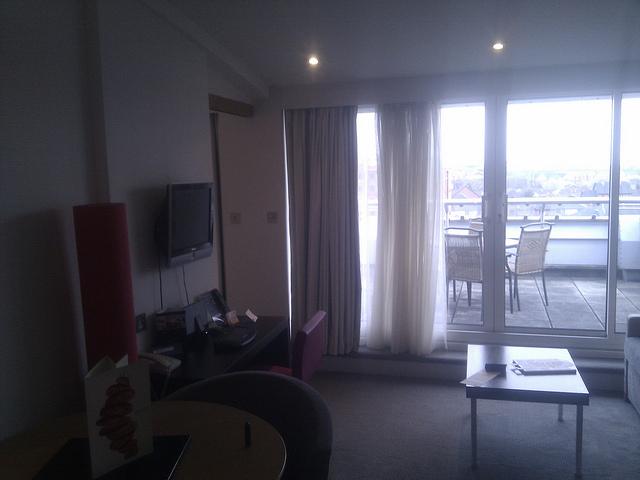What type of scene is it?
Write a very short answer. Living room. Which room is this?
Quick response, please. Living room. What bridge can be seen in the distance?
Give a very brief answer. Golden gate. Where is the balcony?
Quick response, please. Outside. What color are the curtains?
Write a very short answer. White. What style of architecture is this?
Answer briefly. Modern. What material is the floor?
Answer briefly. Carpet. How many lights are on in the room?
Write a very short answer. 2. What might be used to cool the room's temperature?
Give a very brief answer. Air conditioner. What color is the place mat?
Concise answer only. No placemat. 